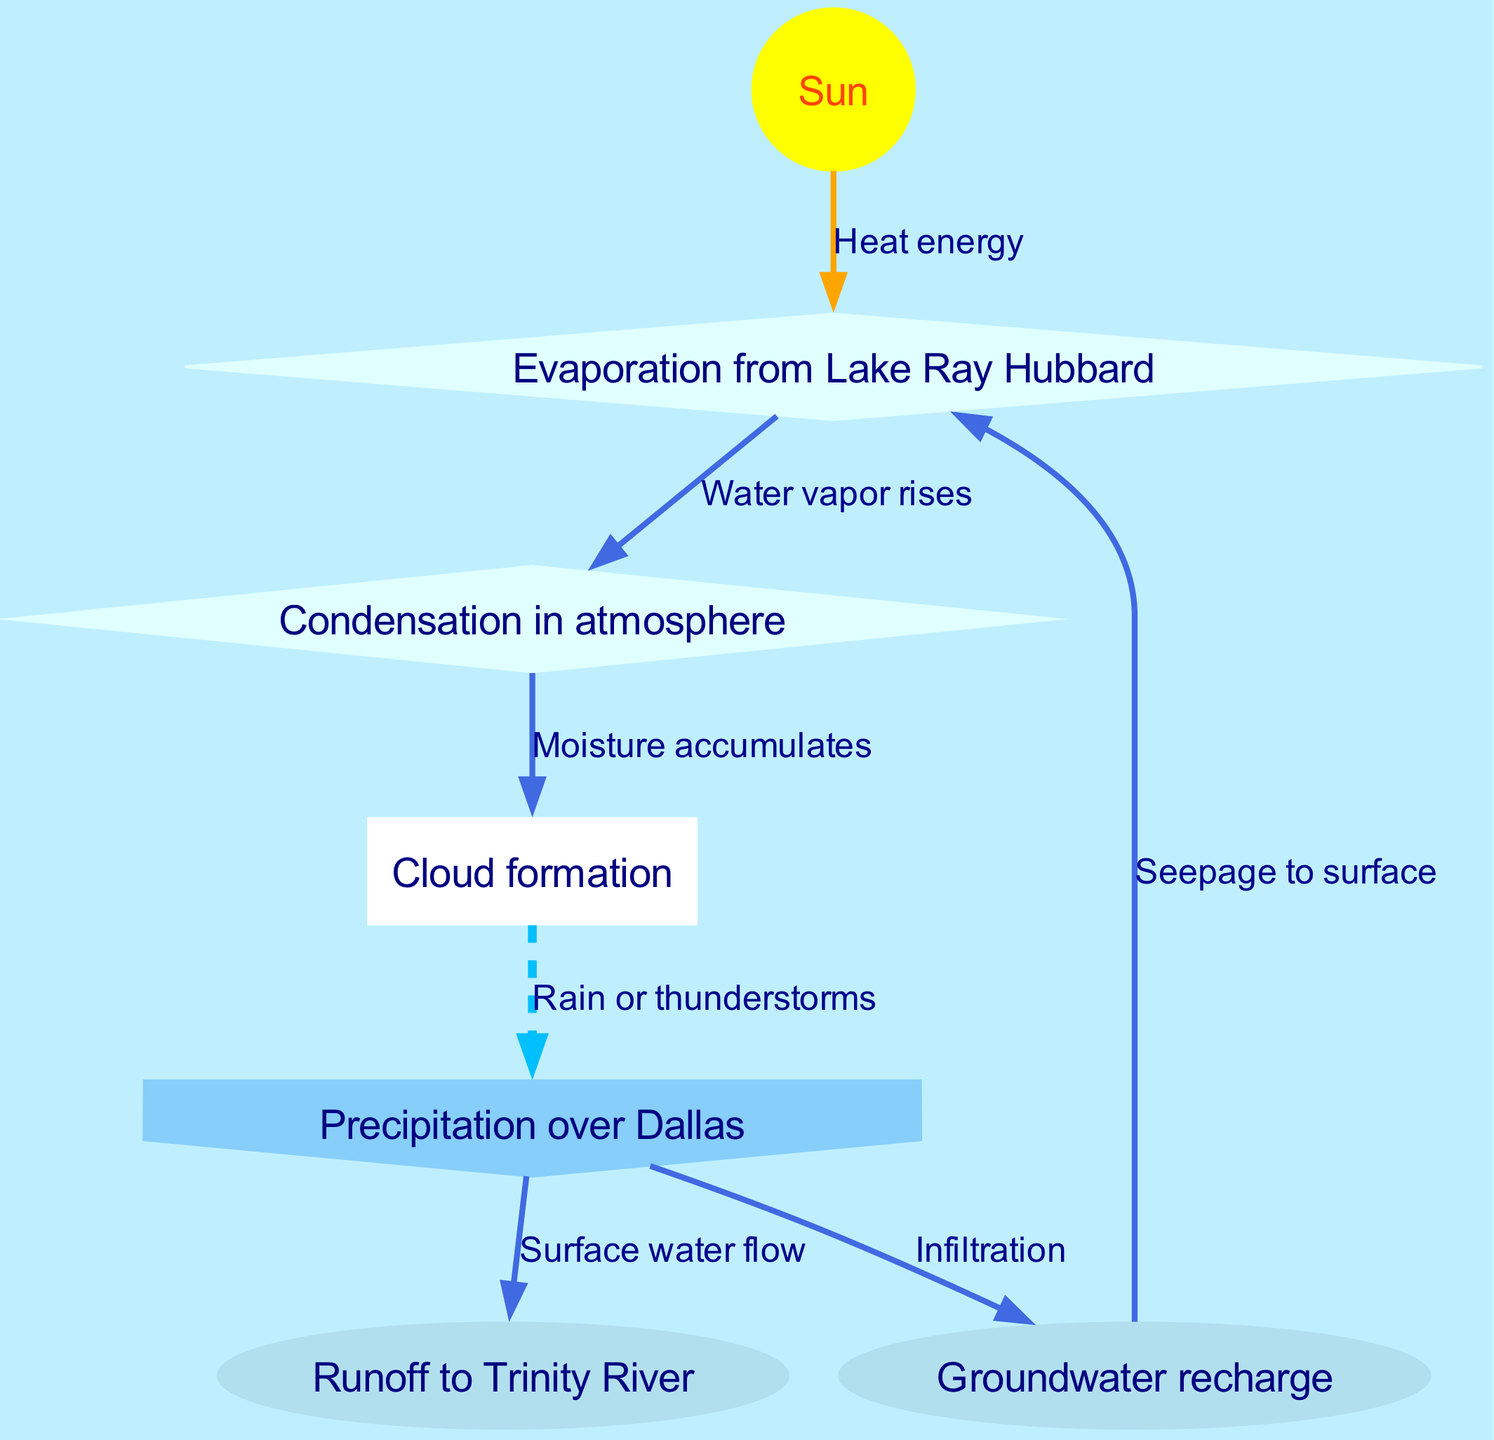What is the source of heat energy in the water cycle? The diagram indicates that the Sun is the source of heat energy, which is shown as the starting point that leads to evaporation.
Answer: Sun How many nodes are present in the water cycle diagram? The diagram includes a total of 7 nodes that represent various stages of the water cycle, including evaporation, condensation, clouds, precipitation, runoff, and groundwater.
Answer: 7 What process occurs when water vapor rises? The diagram shows that when water vapor rises from evaporation, it leads to condensation, indicating the transition from a gas to liquid form in the atmosphere.
Answer: Condensation What is the final result of precipitation in the water cycle? According to the diagram, the outcomes of precipitation include runoff to the Trinity River and groundwater recharge, indicating how water is absorbed or flows away after it falls.
Answer: Runoff and groundwater recharge What shape represents clouds in the diagram? The diagram specifies that clouds are depicted as a cloud shape, which visually differentiates them from other processes in the water cycle.
Answer: Cloud What is the relationship between clouds and precipitation? The edge in the diagram shows a dashed connection between clouds and precipitation, indicating that clouds release moisture in the form of rain or thunderstorms.
Answer: Rain or thunderstorms Which node represents the recharge of underground water? The diagram indicates that groundwater recharge is the node that represents how water permeates the ground and replenishes underground reserves after precipitation.
Answer: Groundwater recharge What occurs after condensation in the water cycle? After condensation, the next process indicated in the diagram is the formation of clouds, which signifies the accumulation of moisture in the atmosphere following condensation.
Answer: Clouds How does groundwater contribute to the water cycle? The diagram illustrates that groundwater seeps to the surface and contributes to evaporation, thereby linking the underground water back to the atmospheric processes in the cycle.
Answer: Seepage to surface 